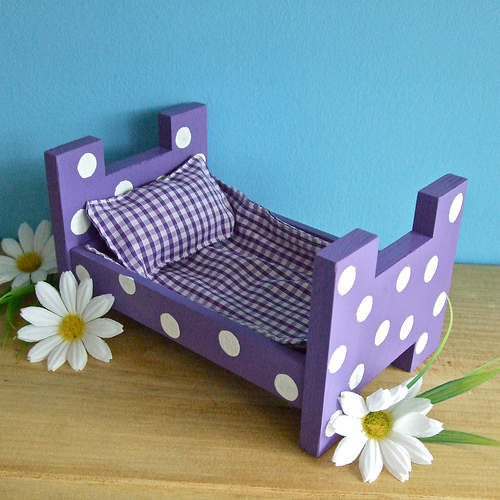<image>
Can you confirm if the bed is on the daisy? Yes. Looking at the image, I can see the bed is positioned on top of the daisy, with the daisy providing support. Is there a flower in front of the bed? Yes. The flower is positioned in front of the bed, appearing closer to the camera viewpoint. 